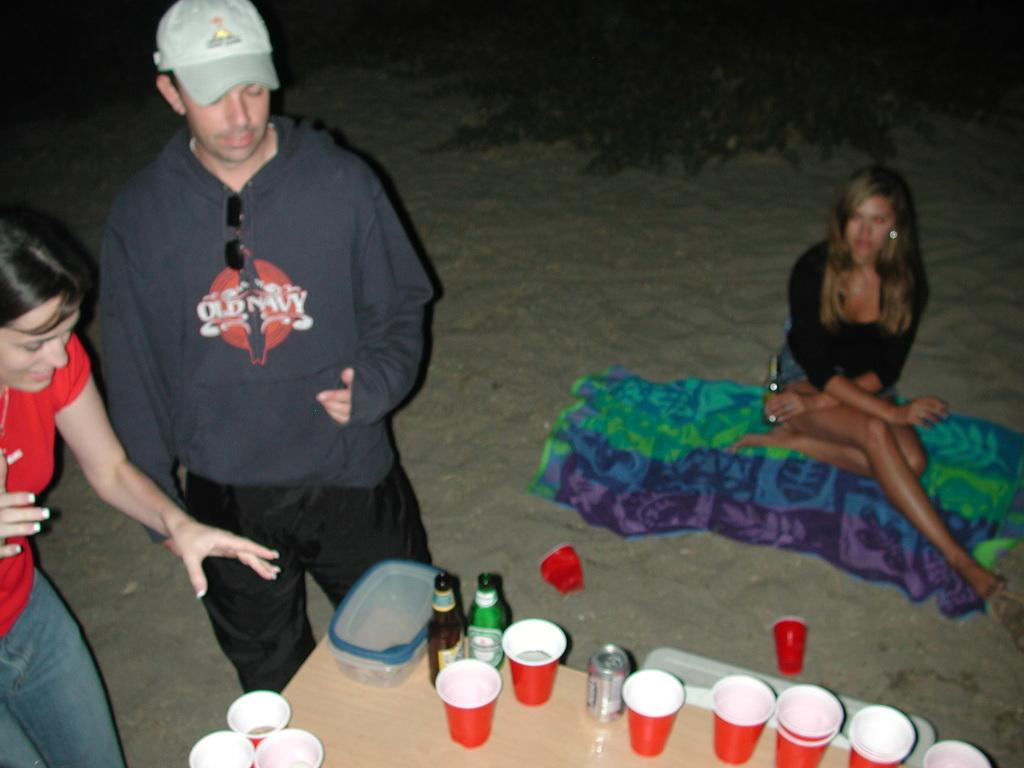What type of setting is depicted in the image? The image is an outdoor scene. How many people are present in the image? There are two persons standing in the image. What is the woman doing in the image? A woman is sitting on a cloth. What furniture is visible in the image? There is a table in the image. What items can be seen on the table? There is a box, bottles, cups, and a tin on the table. Can you tell me how many frogs are hopping on the wrist of the person standing in the image? There are no frogs present in the image, and no one's wrist is visible. 